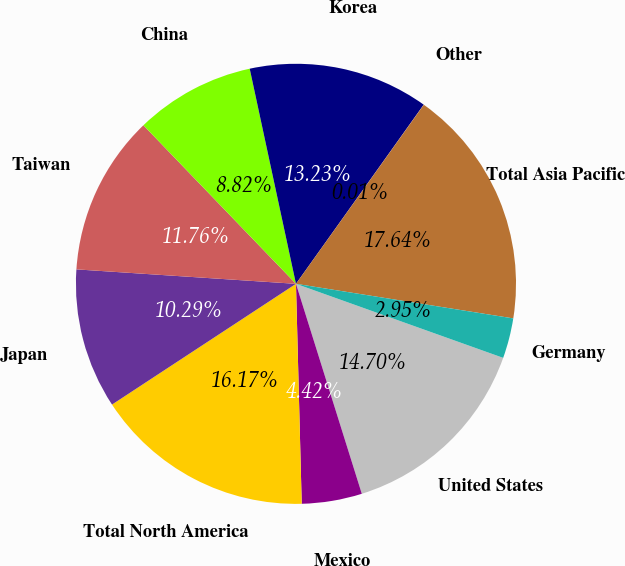Convert chart to OTSL. <chart><loc_0><loc_0><loc_500><loc_500><pie_chart><fcel>United States<fcel>Mexico<fcel>Total North America<fcel>Japan<fcel>Taiwan<fcel>China<fcel>Korea<fcel>Other<fcel>Total Asia Pacific<fcel>Germany<nl><fcel>14.7%<fcel>4.42%<fcel>16.17%<fcel>10.29%<fcel>11.76%<fcel>8.82%<fcel>13.23%<fcel>0.01%<fcel>17.64%<fcel>2.95%<nl></chart> 